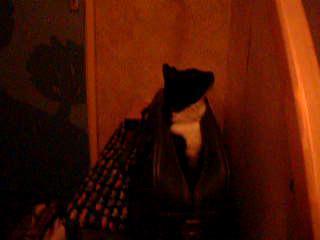How many bags are showing?
Give a very brief answer. 1. 